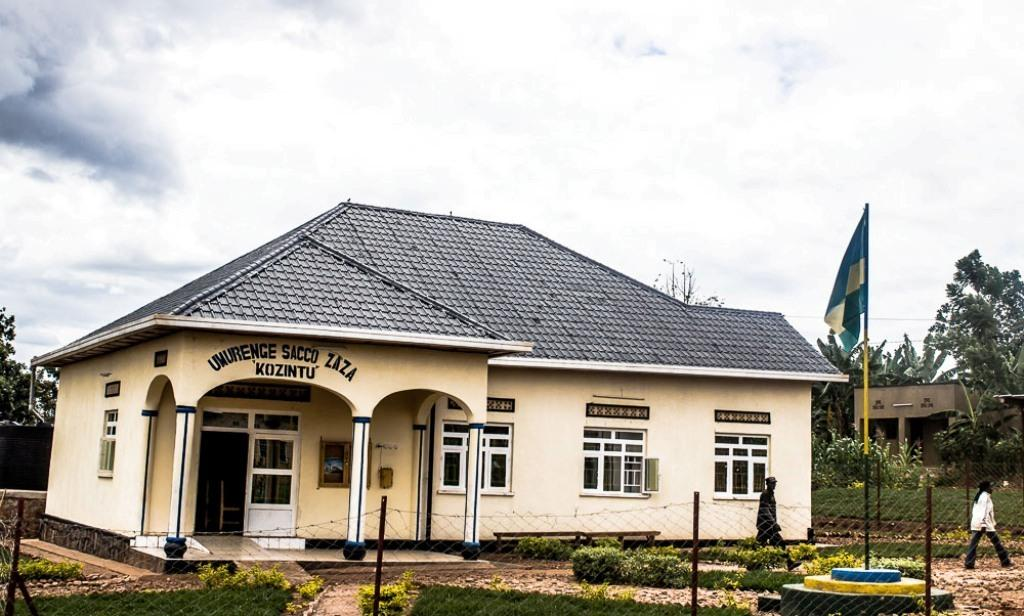What is located in the foreground of the image? In the foreground of the image, there is a fence, grass, a flag, two persons on the road, and houses. Can you describe the ground in the foreground of the image? The ground in the foreground of the image is covered with grass. What is attached to the flagpole in the foreground of the image? A flag is attached to the flagpole in the foreground of the image. How many people are visible in the foreground of the image? Two persons are visible on the road in the foreground of the image. What is visible in the background of the image? The sky is visible in the background of the image. When was the image taken? The image was taken during the day. What type of destruction can be seen happening to the plate in the image? There is no plate present in the image, so no destruction can be observed. What type of soap is being used by the persons in the image? There is no soap visible in the image, and the persons' activities are not described. 